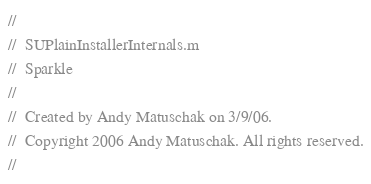<code> <loc_0><loc_0><loc_500><loc_500><_C_>//
//  SUPlainInstallerInternals.m
//  Sparkle
//
//  Created by Andy Matuschak on 3/9/06.
//  Copyright 2006 Andy Matuschak. All rights reserved.
//
</code> 